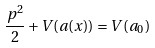Convert formula to latex. <formula><loc_0><loc_0><loc_500><loc_500>\frac { p ^ { 2 } } { 2 } + V ( a ( x ) ) = V ( a _ { 0 } )</formula> 